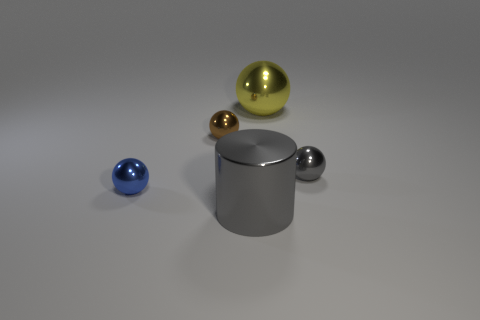Is the number of gray things greater than the number of big yellow spheres? Actually, the number of gray objects is not greater; there is only one gray object visible, which is the large cylinder, whereas there is one big yellow sphere as well. So, the count is equal for both gray objects and big yellow spheres, with one each. 